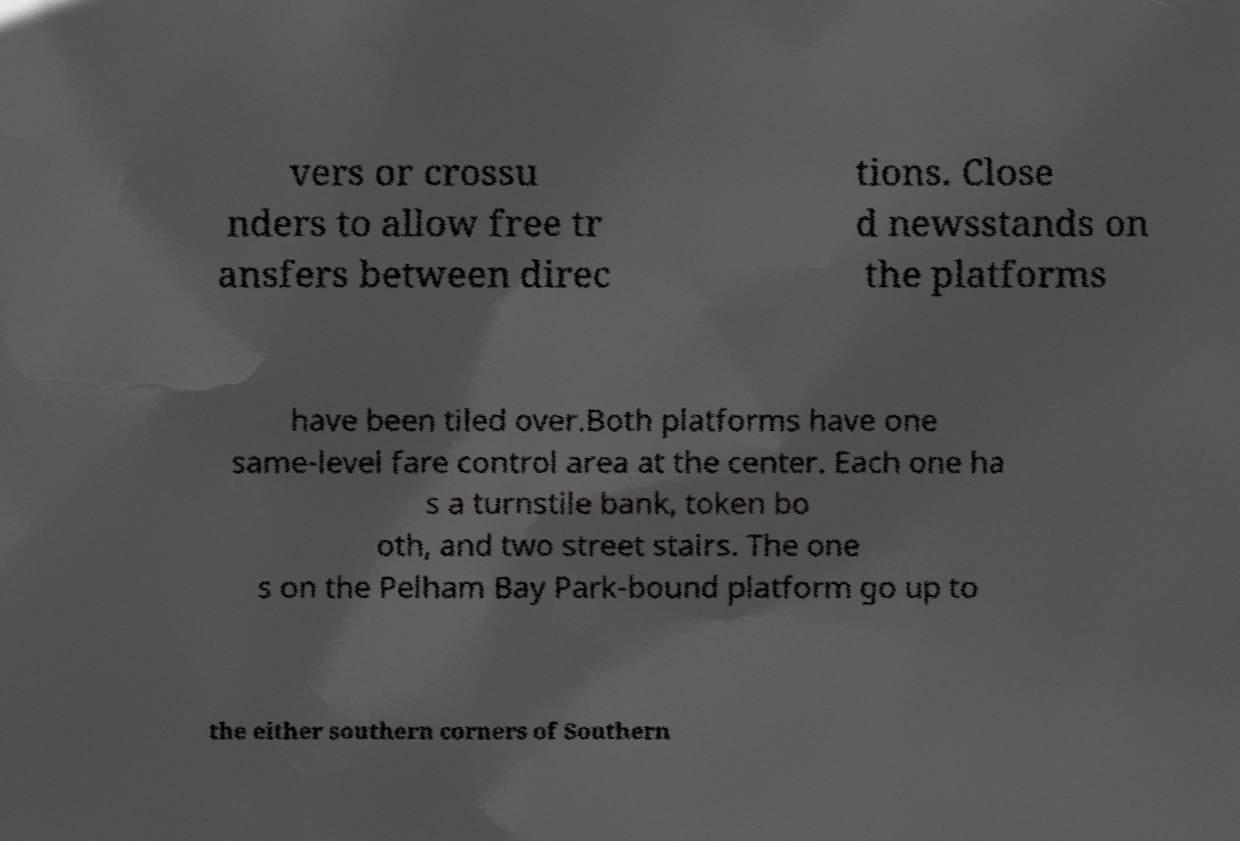I need the written content from this picture converted into text. Can you do that? vers or crossu nders to allow free tr ansfers between direc tions. Close d newsstands on the platforms have been tiled over.Both platforms have one same-level fare control area at the center. Each one ha s a turnstile bank, token bo oth, and two street stairs. The one s on the Pelham Bay Park-bound platform go up to the either southern corners of Southern 